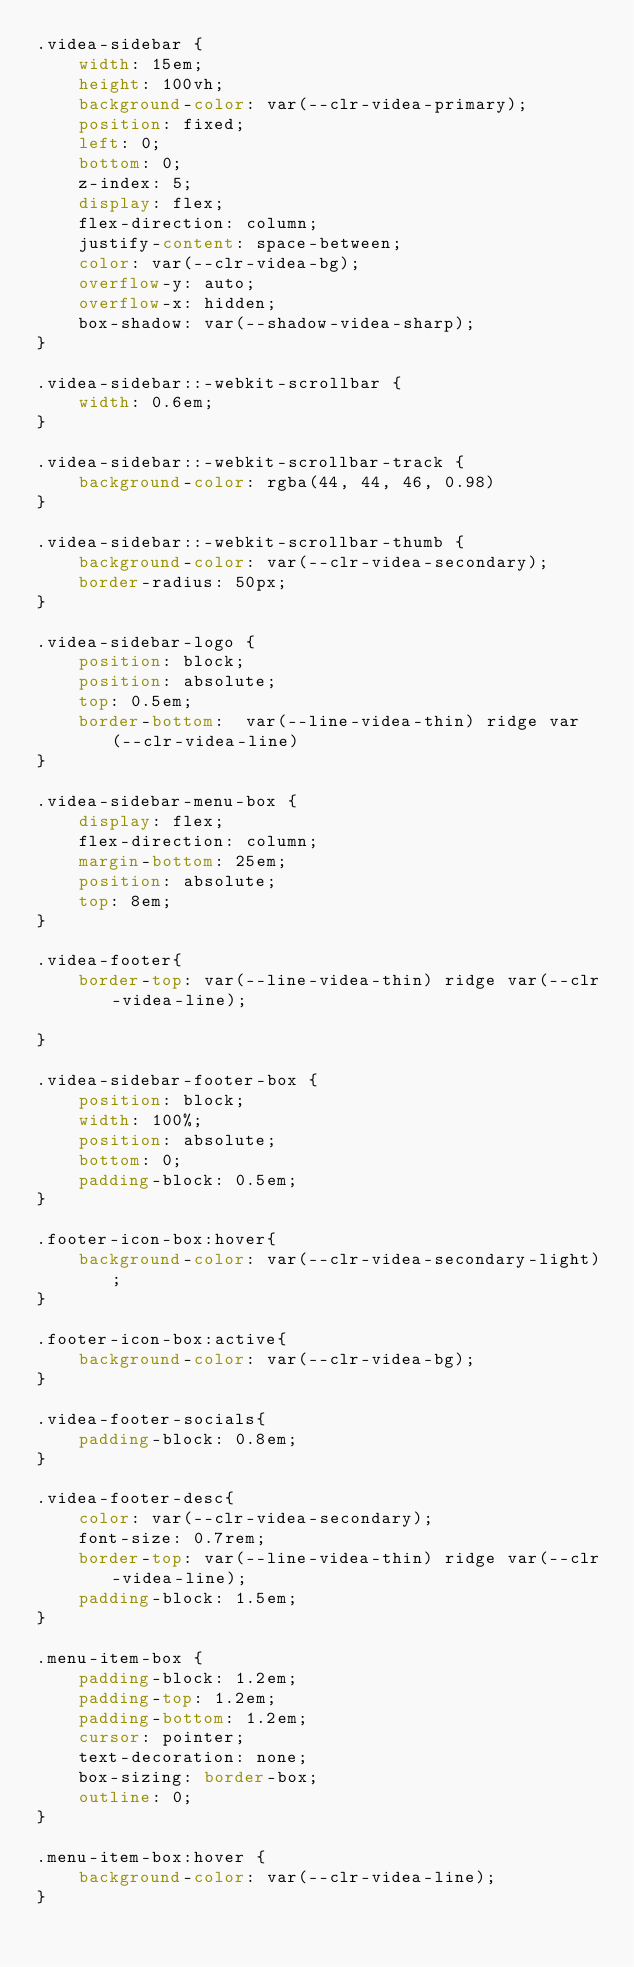<code> <loc_0><loc_0><loc_500><loc_500><_CSS_>.videa-sidebar {
    width: 15em;
    height: 100vh;
    background-color: var(--clr-videa-primary);
    position: fixed;
    left: 0;
    bottom: 0;
    z-index: 5;
    display: flex;
    flex-direction: column;
    justify-content: space-between;
    color: var(--clr-videa-bg);
    overflow-y: auto;
    overflow-x: hidden;
    box-shadow: var(--shadow-videa-sharp);
}

.videa-sidebar::-webkit-scrollbar {
    width: 0.6em;
}

.videa-sidebar::-webkit-scrollbar-track {
    background-color: rgba(44, 44, 46, 0.98)
}

.videa-sidebar::-webkit-scrollbar-thumb {
    background-color: var(--clr-videa-secondary);
    border-radius: 50px;
}

.videa-sidebar-logo {
    position: block;
    position: absolute;
    top: 0.5em;
    border-bottom:  var(--line-videa-thin) ridge var(--clr-videa-line)
}

.videa-sidebar-menu-box {
    display: flex;
    flex-direction: column;
    margin-bottom: 25em;
    position: absolute;
    top: 8em;
}

.videa-footer{
    border-top: var(--line-videa-thin) ridge var(--clr-videa-line);

}

.videa-sidebar-footer-box {
    position: block;
    width: 100%;
    position: absolute;
    bottom: 0;
    padding-block: 0.5em;
}

.footer-icon-box:hover{
    background-color: var(--clr-videa-secondary-light);
}

.footer-icon-box:active{
    background-color: var(--clr-videa-bg);
}

.videa-footer-socials{
    padding-block: 0.8em;
}

.videa-footer-desc{
    color: var(--clr-videa-secondary);
    font-size: 0.7rem;
    border-top: var(--line-videa-thin) ridge var(--clr-videa-line);
    padding-block: 1.5em;
}

.menu-item-box {
    padding-block: 1.2em;
    padding-top: 1.2em;
    padding-bottom: 1.2em;
    cursor: pointer;
    text-decoration: none;
    box-sizing: border-box;
    outline: 0;
}

.menu-item-box:hover {
    background-color: var(--clr-videa-line);
}</code> 